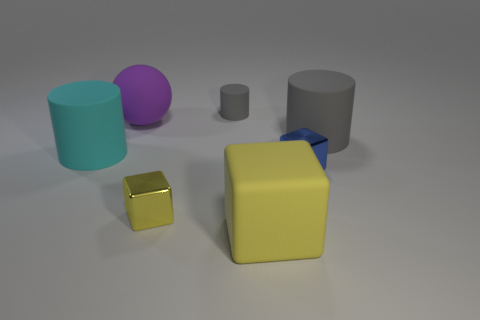Add 3 red rubber objects. How many objects exist? 10 Subtract all cylinders. How many objects are left? 4 Add 1 small cylinders. How many small cylinders are left? 2 Add 5 tiny red metallic cylinders. How many tiny red metallic cylinders exist? 5 Subtract 0 gray spheres. How many objects are left? 7 Subtract all big matte objects. Subtract all big green rubber cylinders. How many objects are left? 3 